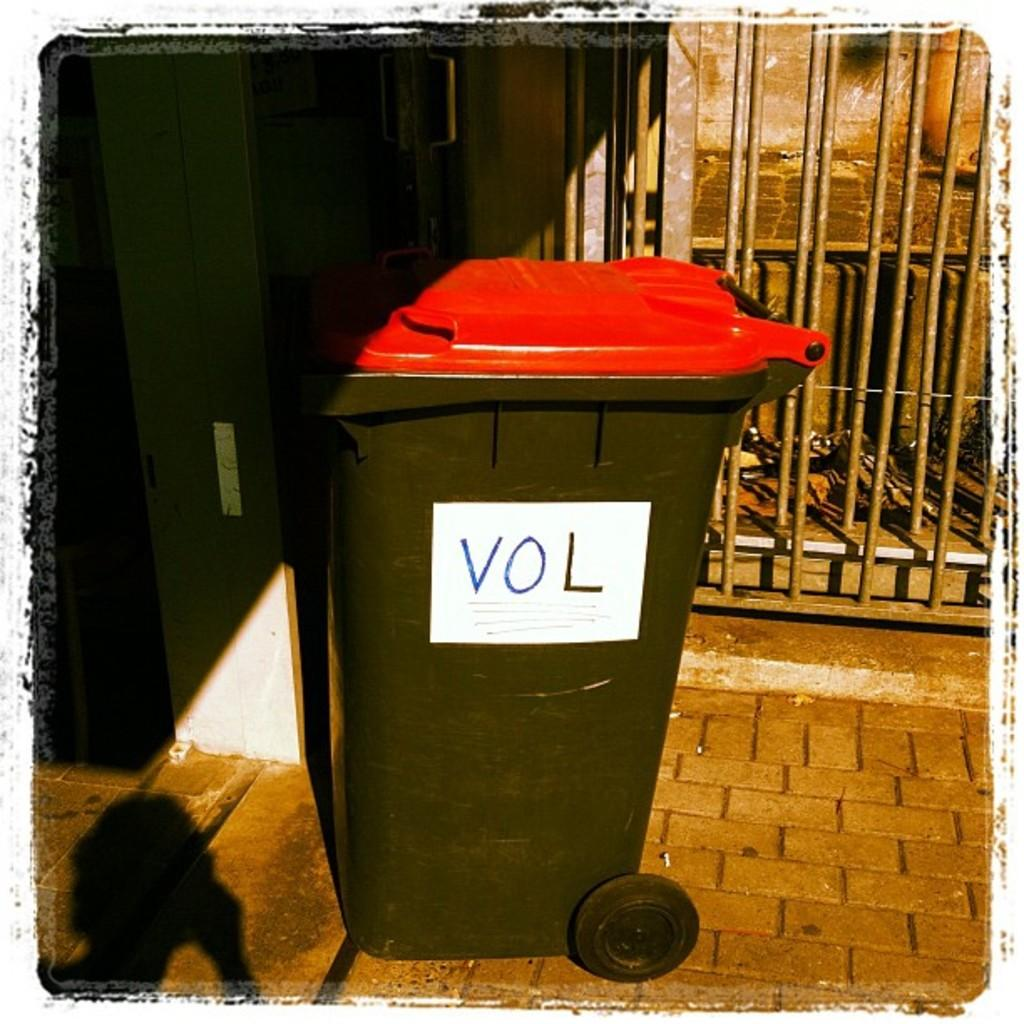<image>
Offer a succinct explanation of the picture presented. A trashcan with VOL written on the side. 